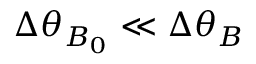<formula> <loc_0><loc_0><loc_500><loc_500>\Delta \theta _ { B _ { 0 } } \ll \Delta \theta _ { B }</formula> 